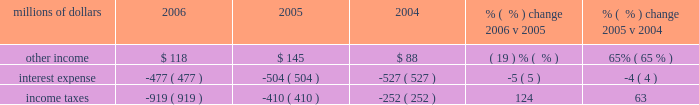Increased over 4% ( 4 % ) in 2005 , costs for trucking services provided by intermodal carriers remained flat as we substantially reduced expenses associated with network inefficiencies .
Higher diesel fuel prices increased sales and use taxes in 2005 , which resulted in higher state and local taxes .
Other contract expenses for equipment maintenance and other services increased in 2005 .
The 2005 january west coast storm and hurricanes katrina and rita also contributed to higher expenses in 2005 ( net of insurance settlements received ) .
Partially offsetting these increases was a reduction in relocation expenses as we incurred higher relocation costs associated with moving support personnel to omaha , nebraska during 2004 .
Non-operating items millions of dollars 2006 2005 2004 % (  % ) change 2006 v 2005 % (  % ) change 2005 v 2004 .
Other income 2013 lower net gains from non-operating asset sales and higher expenses due to rising interest rates associated with our sale of receivables program resulted in a reduction in other income in 2006 , which was partially offset by higher rental income for the use of our right-of-way ( including 2006 settlements of rate disputes from prior years ) and cash investment returns due to higher interest rates .
In 2005 , other income increased largely as a result of higher gains from real estate sales partially offset by higher expenses due to rising interest rates associated with our sale of receivables program .
Interest expense 2013 lower interest expense in 2006 and 2005 was primarily due to declining weighted-average debt levels of $ 7.1 billion , $ 7.8 billion , and $ 8.1 billion in 2006 , 2005 , and 2004 , respectively .
A higher effective interest rate of 6.7% ( 6.7 % ) in 2006 , compared to 6.5% ( 6.5 % ) in both 2005 and 2004 , partially offset the effects of the declining debt level .
Income taxes 2013 income tax expense was $ 509 million higher in 2006 than 2005 .
Higher pre-tax income resulted in additional taxes of $ 414 million and $ 118 million of the increase resulted from the one-time reduction in 2005 described below .
Our effective tax rate was 36.4% ( 36.4 % ) and 28.6% ( 28.6 % ) in 2006 and 2005 , respectively .
Income taxes were greater in 2005 than 2004 due to higher pre-tax income partially offset by a previously reported reduction in income tax expense .
In our quarterly report on form 10-q for the quarter ended june 30 , 2005 , we reported that the corporation analyzed the impact that final settlements of pre-1995 tax years had on previously recorded estimates of deferred tax assets and liabilities .
The completed analysis of the final settlements for pre-1995 tax years , along with internal revenue service examination reports for tax years 1995 through 2002 were considered , among other things , in a review and re-evaluation of the corporation 2019s estimated deferred tax assets and liabilities as of september 30 , 2005 , resulting in an income tax expense reduction of $ 118 million in .
What was the average other income from 2004 to 2006 in millions? 
Computations: (((118 + 145) + 88) / 3)
Answer: 117.0. 